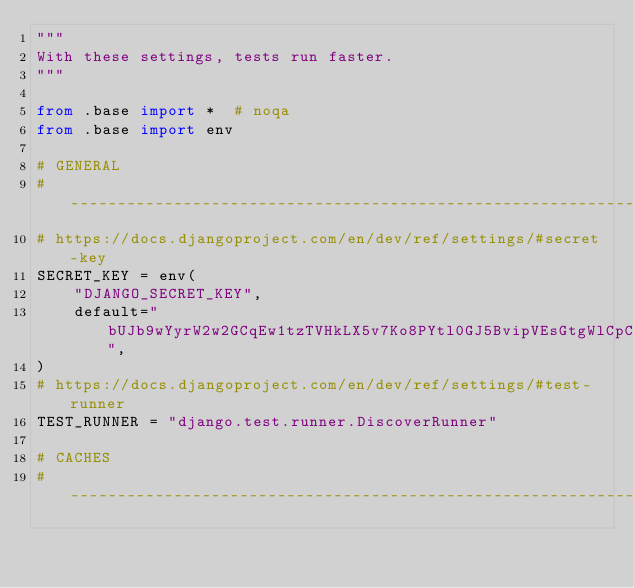<code> <loc_0><loc_0><loc_500><loc_500><_Python_>"""
With these settings, tests run faster.
"""

from .base import *  # noqa
from .base import env

# GENERAL
# ------------------------------------------------------------------------------
# https://docs.djangoproject.com/en/dev/ref/settings/#secret-key
SECRET_KEY = env(
    "DJANGO_SECRET_KEY",
    default="bUJb9wYyrW2w2GCqEw1tzTVHkLX5v7Ko8PYtl0GJ5BvipVEsGtgWlCpCjpO8LbMh",
)
# https://docs.djangoproject.com/en/dev/ref/settings/#test-runner
TEST_RUNNER = "django.test.runner.DiscoverRunner"

# CACHES
# ------------------------------------------------------------------------------</code> 